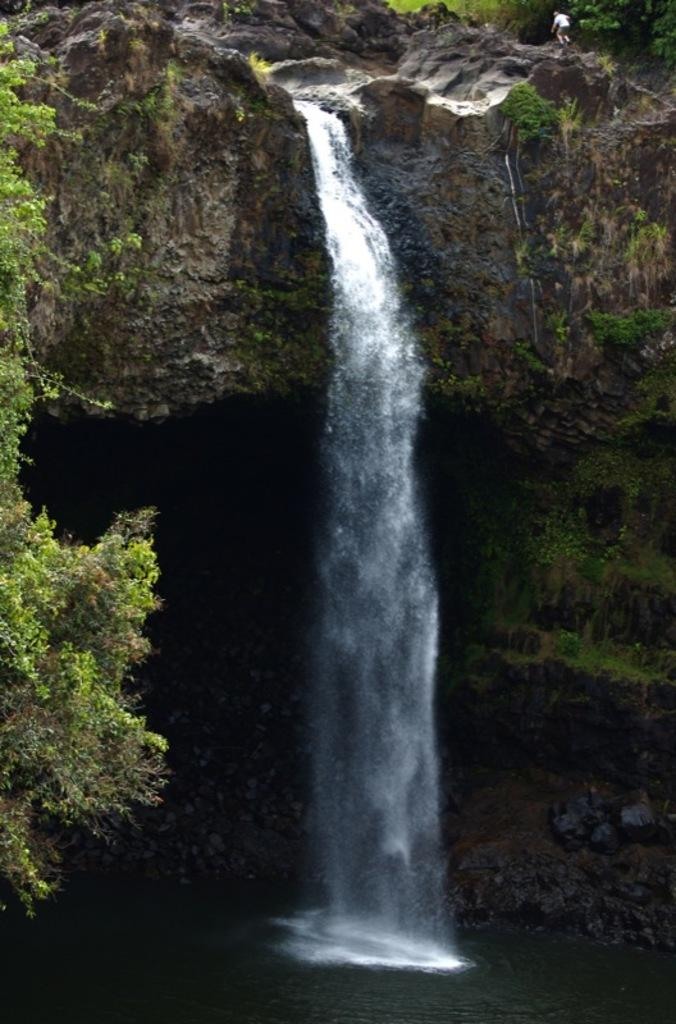What is the source of the water in the image? There is water flowing from a rock in the image. What type of vegetation can be seen in the image? There are plants in the image. What is covering some of the rocks in the image? There is grass on the rocks in the image. Can you describe the person in the image? There is a person walking on the right side of the image. How many degrees can be seen in the image? There are no degrees visible in the image. Are there any dinosaurs present in the image? There are no dinosaurs present in the image. 